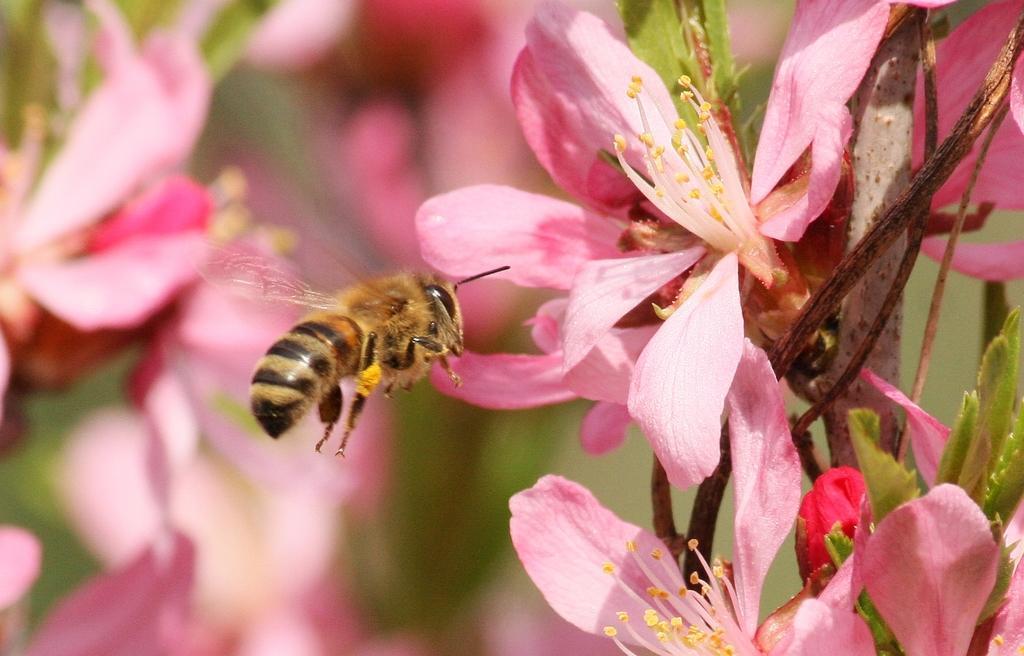How would you summarize this image in a sentence or two? In this image I can see an insect on the flower. And in the background there are flowers and leaves. 